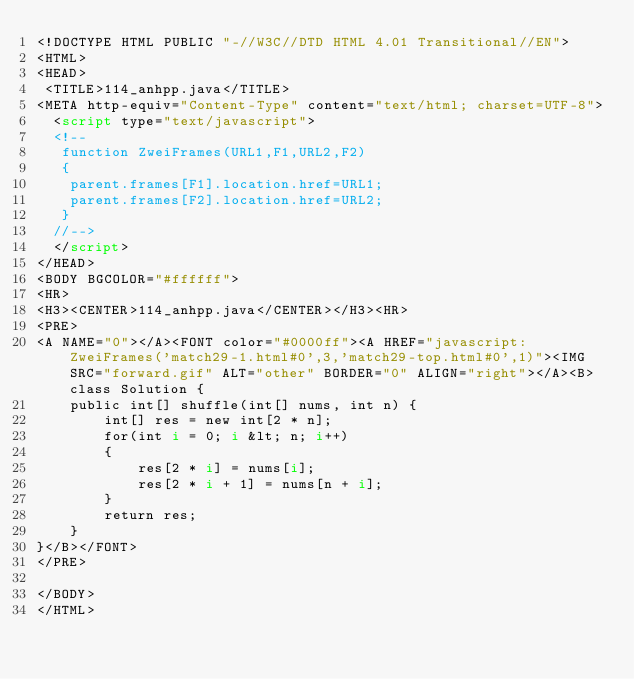<code> <loc_0><loc_0><loc_500><loc_500><_HTML_><!DOCTYPE HTML PUBLIC "-//W3C//DTD HTML 4.01 Transitional//EN">
<HTML>
<HEAD>
 <TITLE>114_anhpp.java</TITLE>
<META http-equiv="Content-Type" content="text/html; charset=UTF-8">
  <script type="text/javascript">
  <!--
   function ZweiFrames(URL1,F1,URL2,F2)
   {
    parent.frames[F1].location.href=URL1;
    parent.frames[F2].location.href=URL2;
   }
  //-->
  </script>
</HEAD>
<BODY BGCOLOR="#ffffff">
<HR>
<H3><CENTER>114_anhpp.java</CENTER></H3><HR>
<PRE>
<A NAME="0"></A><FONT color="#0000ff"><A HREF="javascript:ZweiFrames('match29-1.html#0',3,'match29-top.html#0',1)"><IMG SRC="forward.gif" ALT="other" BORDER="0" ALIGN="right"></A><B>class Solution {
    public int[] shuffle(int[] nums, int n) {
        int[] res = new int[2 * n];
        for(int i = 0; i &lt; n; i++)
        {
            res[2 * i] = nums[i];
            res[2 * i + 1] = nums[n + i];
        }
        return res;
    }
}</B></FONT>
</PRE>

</BODY>
</HTML>
</code> 